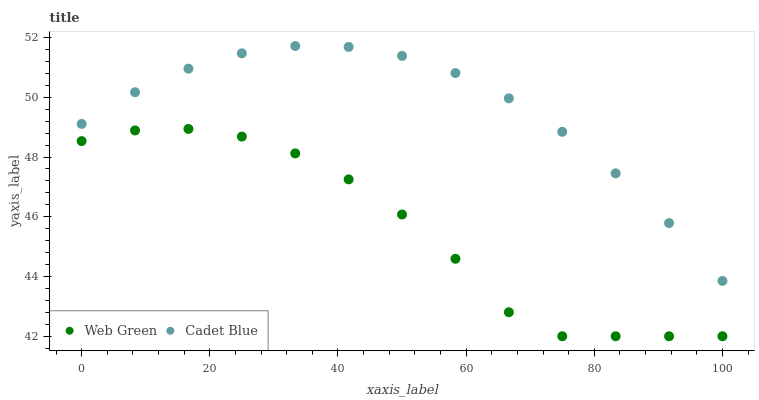Does Web Green have the minimum area under the curve?
Answer yes or no. Yes. Does Cadet Blue have the maximum area under the curve?
Answer yes or no. Yes. Does Web Green have the maximum area under the curve?
Answer yes or no. No. Is Cadet Blue the smoothest?
Answer yes or no. Yes. Is Web Green the roughest?
Answer yes or no. Yes. Is Web Green the smoothest?
Answer yes or no. No. Does Web Green have the lowest value?
Answer yes or no. Yes. Does Cadet Blue have the highest value?
Answer yes or no. Yes. Does Web Green have the highest value?
Answer yes or no. No. Is Web Green less than Cadet Blue?
Answer yes or no. Yes. Is Cadet Blue greater than Web Green?
Answer yes or no. Yes. Does Web Green intersect Cadet Blue?
Answer yes or no. No. 